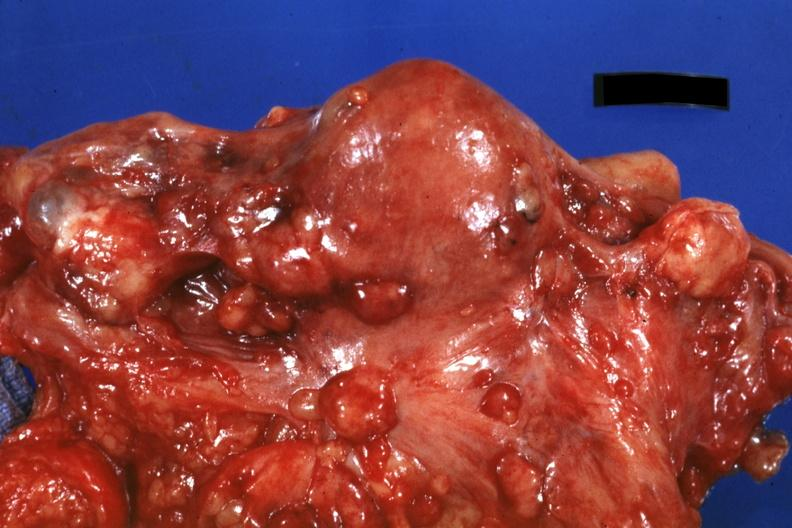how does this image show close-up of uterus and ovaries?
Answer the question using a single word or phrase. With metastatic carcinoma on peritoneal surface 